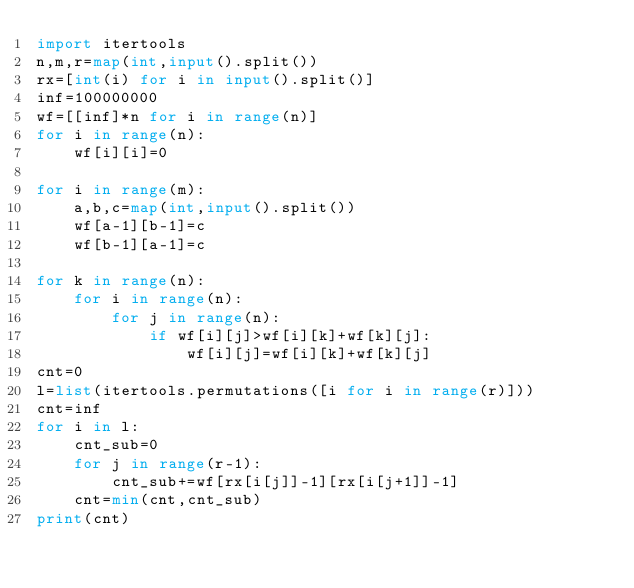<code> <loc_0><loc_0><loc_500><loc_500><_Python_>import itertools
n,m,r=map(int,input().split())
rx=[int(i) for i in input().split()]
inf=100000000
wf=[[inf]*n for i in range(n)]
for i in range(n):
    wf[i][i]=0

for i in range(m):
    a,b,c=map(int,input().split())
    wf[a-1][b-1]=c
    wf[b-1][a-1]=c

for k in range(n):
    for i in range(n):
        for j in range(n):
            if wf[i][j]>wf[i][k]+wf[k][j]:
                wf[i][j]=wf[i][k]+wf[k][j]
cnt=0
l=list(itertools.permutations([i for i in range(r)]))
cnt=inf
for i in l:
    cnt_sub=0
    for j in range(r-1):
        cnt_sub+=wf[rx[i[j]]-1][rx[i[j+1]]-1]
    cnt=min(cnt,cnt_sub)
print(cnt)
</code> 